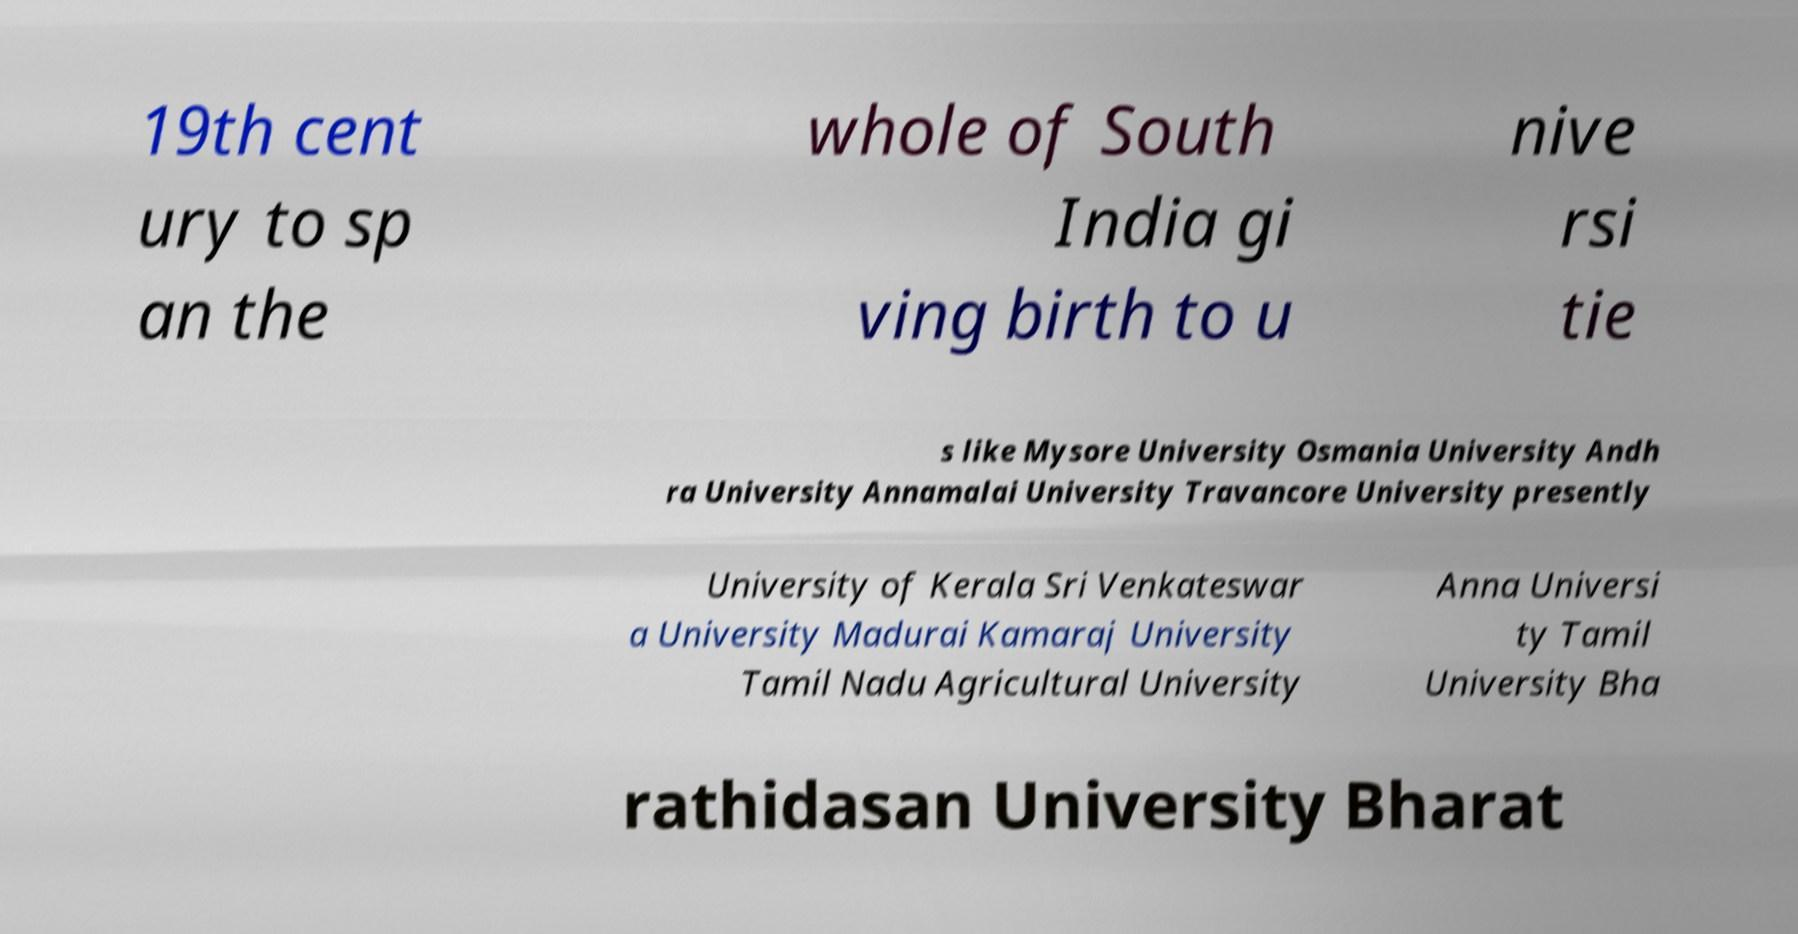For documentation purposes, I need the text within this image transcribed. Could you provide that? 19th cent ury to sp an the whole of South India gi ving birth to u nive rsi tie s like Mysore University Osmania University Andh ra University Annamalai University Travancore University presently University of Kerala Sri Venkateswar a University Madurai Kamaraj University Tamil Nadu Agricultural University Anna Universi ty Tamil University Bha rathidasan University Bharat 